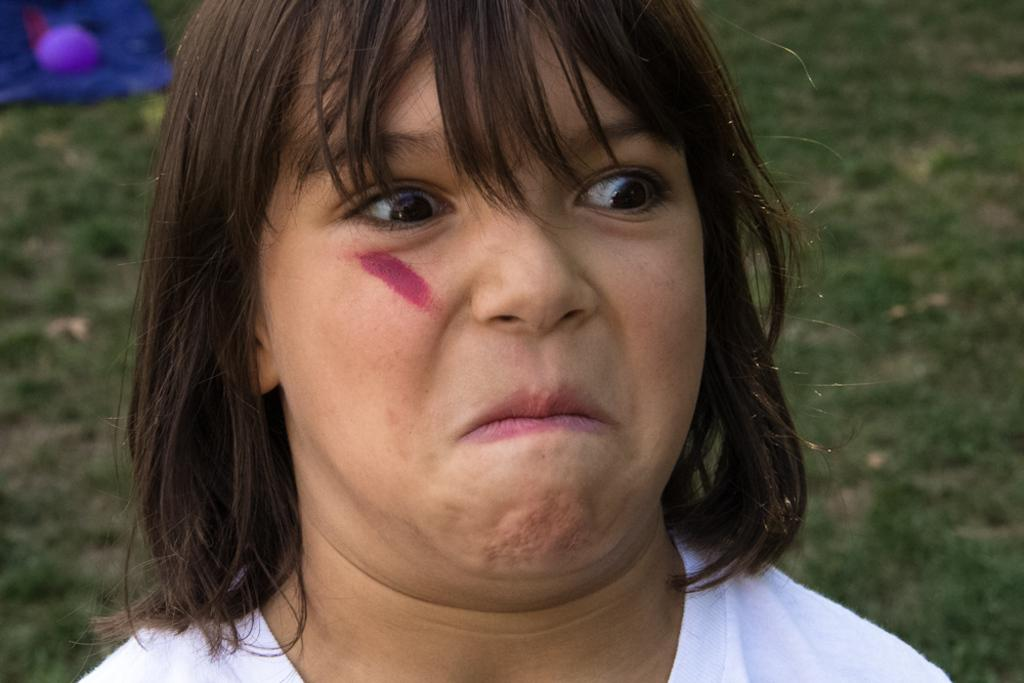Where was the image taken? The image was taken outdoors. What can be seen in the background of the image? There is a ground with grass in the background. Who is the main subject in the image? There is a girl with a weird face in the middle of the image. What type of development can be seen in the background of the image? There is no development visible in the background of the image; it only shows a ground with grass. What kind of bun is the girl holding in the image? The girl is not holding a bun in the image; she has a weird face expression. 